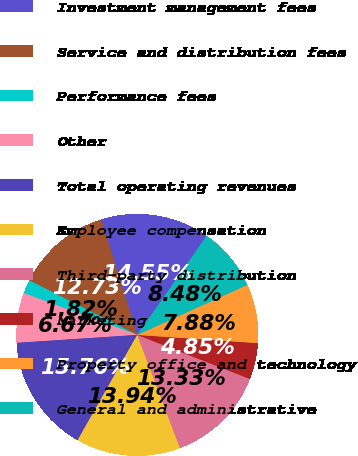Convert chart. <chart><loc_0><loc_0><loc_500><loc_500><pie_chart><fcel>Investment management fees<fcel>Service and distribution fees<fcel>Performance fees<fcel>Other<fcel>Total operating revenues<fcel>Employee compensation<fcel>Third-party distribution<fcel>Marketing<fcel>Property office and technology<fcel>General and administrative<nl><fcel>14.55%<fcel>12.73%<fcel>1.82%<fcel>6.67%<fcel>15.76%<fcel>13.94%<fcel>13.33%<fcel>4.85%<fcel>7.88%<fcel>8.48%<nl></chart> 